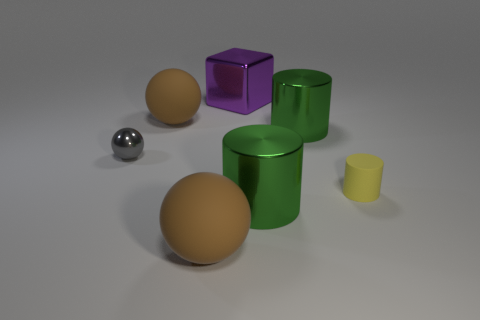Is the material of the small thing that is on the left side of the big purple metal thing the same as the green thing that is behind the yellow cylinder?
Provide a succinct answer. Yes. What is the shape of the large thing that is both in front of the tiny gray ball and on the right side of the big purple thing?
Provide a succinct answer. Cylinder. There is a object that is both behind the tiny gray shiny object and on the left side of the large purple metal cube; what is its material?
Give a very brief answer. Rubber. What shape is the small thing that is the same material as the block?
Provide a short and direct response. Sphere. Is there any other thing that has the same color as the shiny block?
Provide a succinct answer. No. Is the number of large green shiny cylinders that are behind the small yellow rubber cylinder greater than the number of gray blocks?
Offer a very short reply. Yes. What material is the cube?
Give a very brief answer. Metal. What number of shiny objects have the same size as the yellow matte object?
Keep it short and to the point. 1. Are there an equal number of big cylinders that are behind the small cylinder and tiny metal spheres in front of the gray metallic object?
Your response must be concise. No. Do the yellow cylinder and the gray ball have the same material?
Your response must be concise. No. 